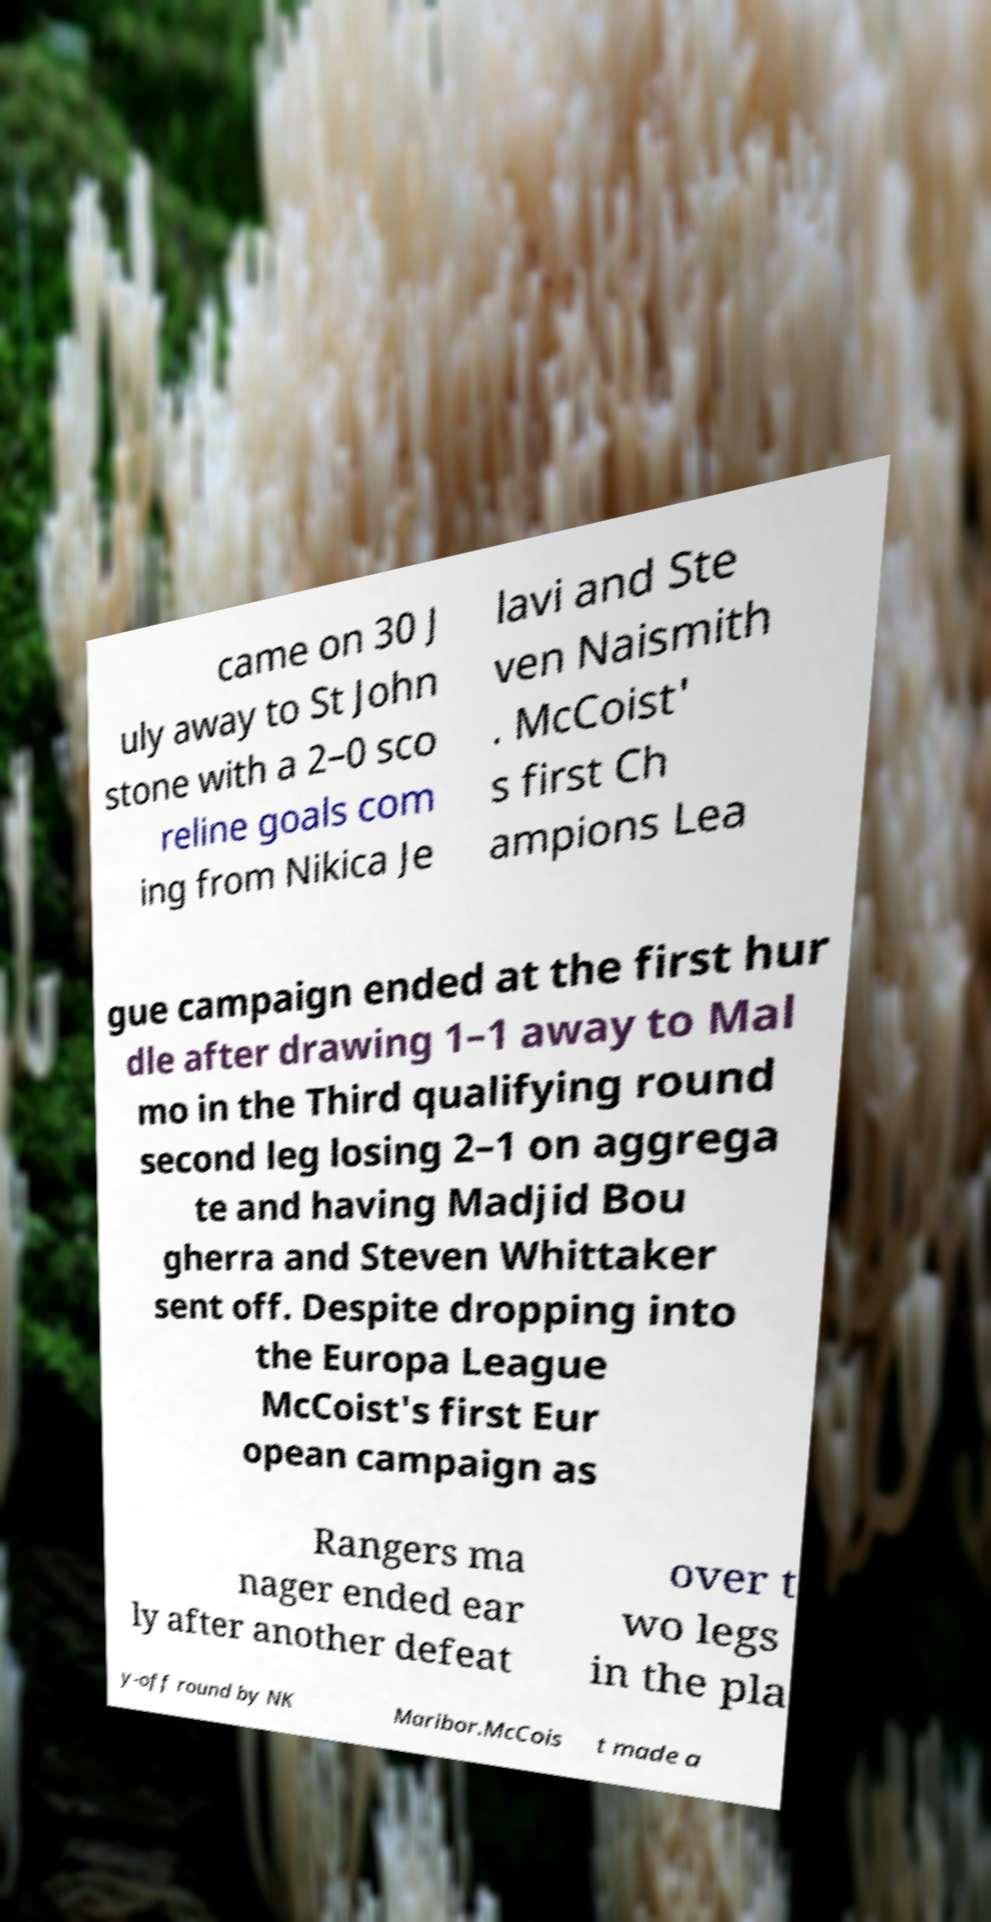Can you read and provide the text displayed in the image?This photo seems to have some interesting text. Can you extract and type it out for me? came on 30 J uly away to St John stone with a 2–0 sco reline goals com ing from Nikica Je lavi and Ste ven Naismith . McCoist' s first Ch ampions Lea gue campaign ended at the first hur dle after drawing 1–1 away to Mal mo in the Third qualifying round second leg losing 2–1 on aggrega te and having Madjid Bou gherra and Steven Whittaker sent off. Despite dropping into the Europa League McCoist's first Eur opean campaign as Rangers ma nager ended ear ly after another defeat over t wo legs in the pla y-off round by NK Maribor.McCois t made a 